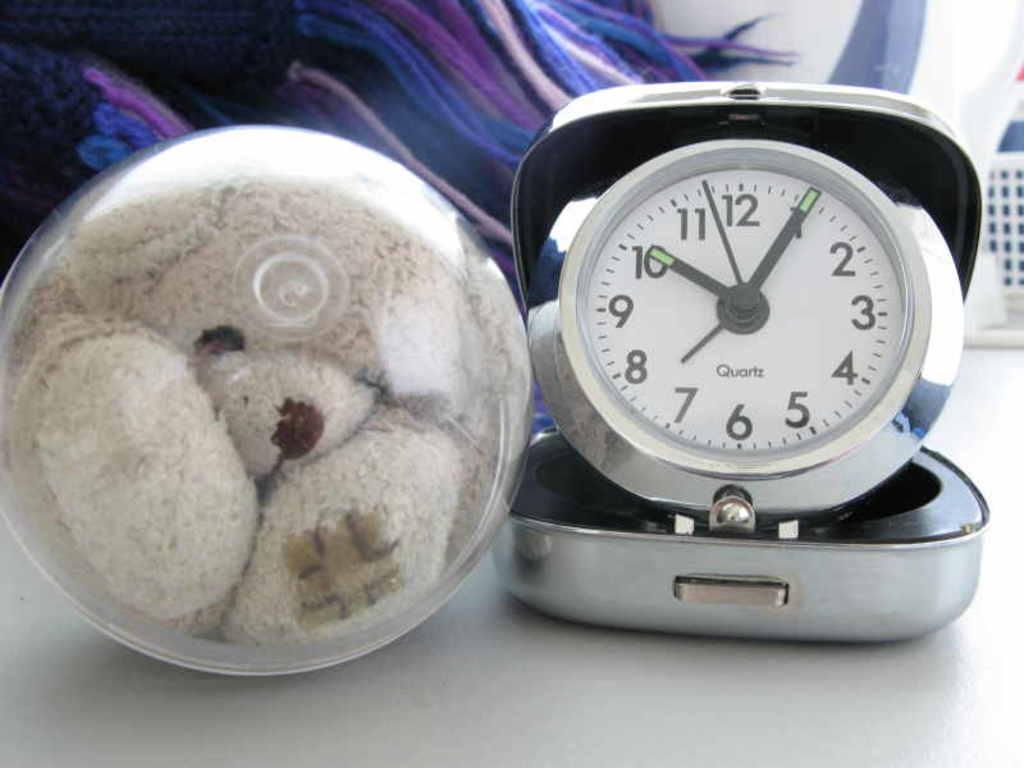What time is shown on the clock?
Provide a succinct answer. 10:05. What brand is the clock?
Your answer should be compact. Quartz. 